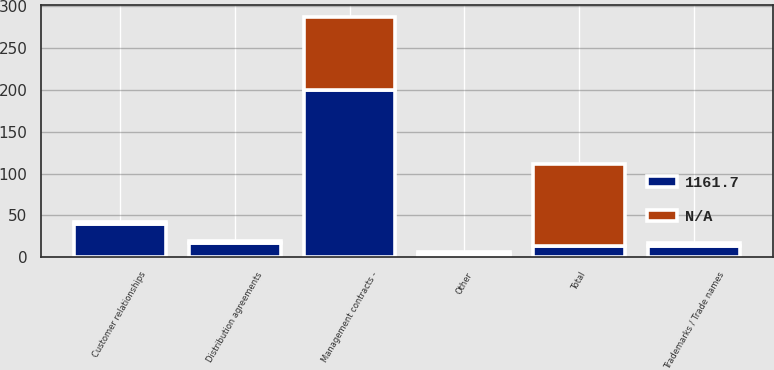<chart> <loc_0><loc_0><loc_500><loc_500><stacked_bar_chart><ecel><fcel>Management contracts -<fcel>Customer relationships<fcel>Distribution agreements<fcel>Trademarks / Trade names<fcel>Other<fcel>Total<nl><fcel>1161.7<fcel>199.7<fcel>40<fcel>17<fcel>13<fcel>3.6<fcel>13<nl><fcel>nan<fcel>87<fcel>1.9<fcel>2.5<fcel>3.8<fcel>2.6<fcel>97.8<nl></chart> 